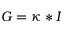<formula> <loc_0><loc_0><loc_500><loc_500>G = \kappa * I</formula> 